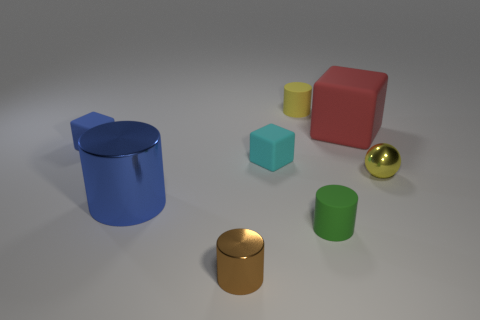Subtract all big red rubber blocks. How many blocks are left? 2 Subtract all brown cylinders. How many cylinders are left? 3 Subtract 1 blocks. How many blocks are left? 2 Add 2 small gray metallic spheres. How many objects exist? 10 Subtract all balls. How many objects are left? 7 Add 5 tiny brown shiny cylinders. How many tiny brown shiny cylinders are left? 6 Add 8 small green metal cylinders. How many small green metal cylinders exist? 8 Subtract 0 cyan cylinders. How many objects are left? 8 Subtract all red cylinders. Subtract all purple balls. How many cylinders are left? 4 Subtract all cyan cubes. Subtract all blue metal objects. How many objects are left? 6 